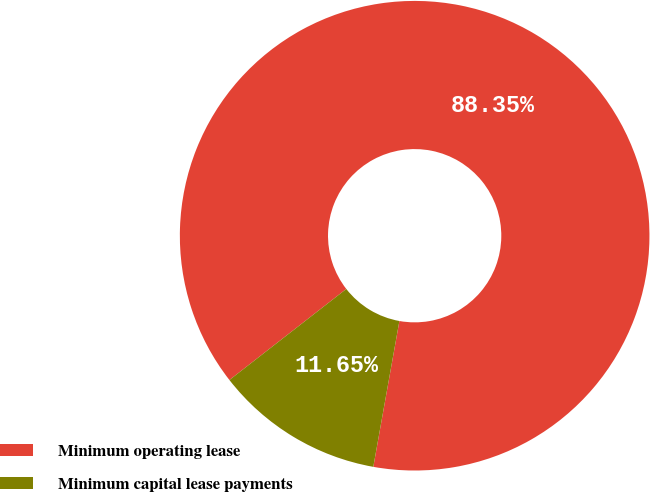Convert chart. <chart><loc_0><loc_0><loc_500><loc_500><pie_chart><fcel>Minimum operating lease<fcel>Minimum capital lease payments<nl><fcel>88.35%<fcel>11.65%<nl></chart> 